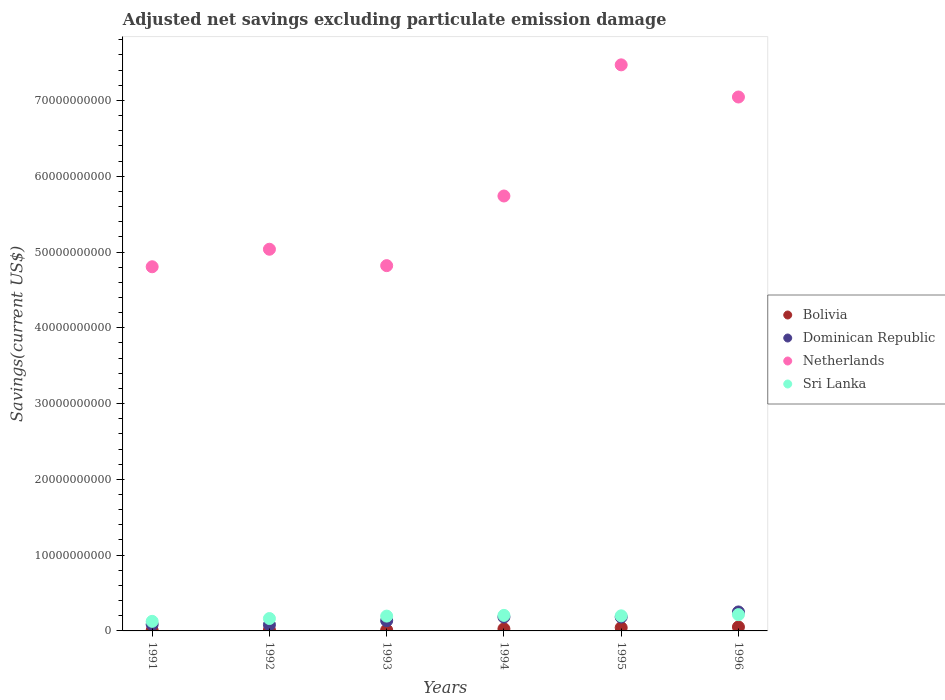What is the adjusted net savings in Dominican Republic in 1995?
Provide a short and direct response. 1.83e+09. Across all years, what is the maximum adjusted net savings in Bolivia?
Your answer should be very brief. 5.21e+08. Across all years, what is the minimum adjusted net savings in Netherlands?
Ensure brevity in your answer.  4.81e+1. In which year was the adjusted net savings in Sri Lanka maximum?
Give a very brief answer. 1996. In which year was the adjusted net savings in Netherlands minimum?
Make the answer very short. 1991. What is the total adjusted net savings in Dominican Republic in the graph?
Your response must be concise. 9.19e+09. What is the difference between the adjusted net savings in Bolivia in 1992 and that in 1995?
Provide a short and direct response. -3.08e+08. What is the difference between the adjusted net savings in Bolivia in 1992 and the adjusted net savings in Netherlands in 1994?
Ensure brevity in your answer.  -5.73e+1. What is the average adjusted net savings in Netherlands per year?
Provide a succinct answer. 5.82e+1. In the year 1996, what is the difference between the adjusted net savings in Sri Lanka and adjusted net savings in Netherlands?
Your response must be concise. -6.83e+1. What is the ratio of the adjusted net savings in Dominican Republic in 1992 to that in 1996?
Your answer should be very brief. 0.33. Is the adjusted net savings in Netherlands in 1991 less than that in 1996?
Provide a succinct answer. Yes. Is the difference between the adjusted net savings in Sri Lanka in 1992 and 1996 greater than the difference between the adjusted net savings in Netherlands in 1992 and 1996?
Your answer should be very brief. Yes. What is the difference between the highest and the second highest adjusted net savings in Bolivia?
Provide a short and direct response. 9.21e+07. What is the difference between the highest and the lowest adjusted net savings in Netherlands?
Keep it short and to the point. 2.66e+1. Is the sum of the adjusted net savings in Dominican Republic in 1993 and 1994 greater than the maximum adjusted net savings in Netherlands across all years?
Provide a short and direct response. No. Is it the case that in every year, the sum of the adjusted net savings in Netherlands and adjusted net savings in Dominican Republic  is greater than the sum of adjusted net savings in Sri Lanka and adjusted net savings in Bolivia?
Your answer should be very brief. No. Is the adjusted net savings in Sri Lanka strictly greater than the adjusted net savings in Bolivia over the years?
Offer a terse response. Yes. Is the adjusted net savings in Bolivia strictly less than the adjusted net savings in Sri Lanka over the years?
Your answer should be compact. Yes. How many years are there in the graph?
Keep it short and to the point. 6. What is the difference between two consecutive major ticks on the Y-axis?
Your answer should be compact. 1.00e+1. Does the graph contain any zero values?
Provide a succinct answer. No. Does the graph contain grids?
Keep it short and to the point. No. What is the title of the graph?
Make the answer very short. Adjusted net savings excluding particulate emission damage. Does "Portugal" appear as one of the legend labels in the graph?
Keep it short and to the point. No. What is the label or title of the Y-axis?
Provide a short and direct response. Savings(current US$). What is the Savings(current US$) in Bolivia in 1991?
Your answer should be very brief. 7.90e+07. What is the Savings(current US$) of Dominican Republic in 1991?
Make the answer very short. 8.60e+08. What is the Savings(current US$) of Netherlands in 1991?
Provide a succinct answer. 4.81e+1. What is the Savings(current US$) in Sri Lanka in 1991?
Provide a succinct answer. 1.26e+09. What is the Savings(current US$) in Bolivia in 1992?
Your answer should be compact. 1.20e+08. What is the Savings(current US$) of Dominican Republic in 1992?
Provide a short and direct response. 8.15e+08. What is the Savings(current US$) in Netherlands in 1992?
Offer a terse response. 5.04e+1. What is the Savings(current US$) in Sri Lanka in 1992?
Your response must be concise. 1.63e+09. What is the Savings(current US$) in Bolivia in 1993?
Provide a succinct answer. 1.12e+08. What is the Savings(current US$) of Dominican Republic in 1993?
Provide a succinct answer. 1.35e+09. What is the Savings(current US$) in Netherlands in 1993?
Ensure brevity in your answer.  4.82e+1. What is the Savings(current US$) of Sri Lanka in 1993?
Keep it short and to the point. 1.96e+09. What is the Savings(current US$) of Bolivia in 1994?
Give a very brief answer. 2.69e+08. What is the Savings(current US$) in Dominican Republic in 1994?
Provide a short and direct response. 1.84e+09. What is the Savings(current US$) in Netherlands in 1994?
Your response must be concise. 5.74e+1. What is the Savings(current US$) of Sri Lanka in 1994?
Offer a terse response. 2.05e+09. What is the Savings(current US$) in Bolivia in 1995?
Give a very brief answer. 4.28e+08. What is the Savings(current US$) in Dominican Republic in 1995?
Your answer should be compact. 1.83e+09. What is the Savings(current US$) of Netherlands in 1995?
Offer a very short reply. 7.47e+1. What is the Savings(current US$) of Sri Lanka in 1995?
Your response must be concise. 1.99e+09. What is the Savings(current US$) of Bolivia in 1996?
Your answer should be very brief. 5.21e+08. What is the Savings(current US$) of Dominican Republic in 1996?
Make the answer very short. 2.50e+09. What is the Savings(current US$) in Netherlands in 1996?
Make the answer very short. 7.05e+1. What is the Savings(current US$) of Sri Lanka in 1996?
Provide a short and direct response. 2.15e+09. Across all years, what is the maximum Savings(current US$) in Bolivia?
Make the answer very short. 5.21e+08. Across all years, what is the maximum Savings(current US$) in Dominican Republic?
Provide a succinct answer. 2.50e+09. Across all years, what is the maximum Savings(current US$) in Netherlands?
Your answer should be very brief. 7.47e+1. Across all years, what is the maximum Savings(current US$) of Sri Lanka?
Offer a terse response. 2.15e+09. Across all years, what is the minimum Savings(current US$) in Bolivia?
Provide a succinct answer. 7.90e+07. Across all years, what is the minimum Savings(current US$) of Dominican Republic?
Your response must be concise. 8.15e+08. Across all years, what is the minimum Savings(current US$) of Netherlands?
Give a very brief answer. 4.81e+1. Across all years, what is the minimum Savings(current US$) in Sri Lanka?
Your answer should be very brief. 1.26e+09. What is the total Savings(current US$) of Bolivia in the graph?
Provide a short and direct response. 1.53e+09. What is the total Savings(current US$) of Dominican Republic in the graph?
Make the answer very short. 9.19e+09. What is the total Savings(current US$) of Netherlands in the graph?
Your answer should be compact. 3.49e+11. What is the total Savings(current US$) of Sri Lanka in the graph?
Your answer should be compact. 1.10e+1. What is the difference between the Savings(current US$) of Bolivia in 1991 and that in 1992?
Keep it short and to the point. -4.12e+07. What is the difference between the Savings(current US$) in Dominican Republic in 1991 and that in 1992?
Provide a short and direct response. 4.44e+07. What is the difference between the Savings(current US$) in Netherlands in 1991 and that in 1992?
Offer a terse response. -2.31e+09. What is the difference between the Savings(current US$) in Sri Lanka in 1991 and that in 1992?
Your response must be concise. -3.70e+08. What is the difference between the Savings(current US$) in Bolivia in 1991 and that in 1993?
Ensure brevity in your answer.  -3.27e+07. What is the difference between the Savings(current US$) in Dominican Republic in 1991 and that in 1993?
Make the answer very short. -4.86e+08. What is the difference between the Savings(current US$) of Netherlands in 1991 and that in 1993?
Give a very brief answer. -1.47e+08. What is the difference between the Savings(current US$) of Sri Lanka in 1991 and that in 1993?
Provide a succinct answer. -6.92e+08. What is the difference between the Savings(current US$) in Bolivia in 1991 and that in 1994?
Provide a succinct answer. -1.90e+08. What is the difference between the Savings(current US$) in Dominican Republic in 1991 and that in 1994?
Your answer should be very brief. -9.76e+08. What is the difference between the Savings(current US$) in Netherlands in 1991 and that in 1994?
Provide a short and direct response. -9.34e+09. What is the difference between the Savings(current US$) in Sri Lanka in 1991 and that in 1994?
Your answer should be compact. -7.87e+08. What is the difference between the Savings(current US$) in Bolivia in 1991 and that in 1995?
Make the answer very short. -3.49e+08. What is the difference between the Savings(current US$) of Dominican Republic in 1991 and that in 1995?
Give a very brief answer. -9.70e+08. What is the difference between the Savings(current US$) of Netherlands in 1991 and that in 1995?
Provide a short and direct response. -2.66e+1. What is the difference between the Savings(current US$) in Sri Lanka in 1991 and that in 1995?
Provide a succinct answer. -7.28e+08. What is the difference between the Savings(current US$) of Bolivia in 1991 and that in 1996?
Give a very brief answer. -4.42e+08. What is the difference between the Savings(current US$) of Dominican Republic in 1991 and that in 1996?
Your answer should be very brief. -1.64e+09. What is the difference between the Savings(current US$) of Netherlands in 1991 and that in 1996?
Give a very brief answer. -2.24e+1. What is the difference between the Savings(current US$) of Sri Lanka in 1991 and that in 1996?
Ensure brevity in your answer.  -8.87e+08. What is the difference between the Savings(current US$) of Bolivia in 1992 and that in 1993?
Give a very brief answer. 8.44e+06. What is the difference between the Savings(current US$) in Dominican Republic in 1992 and that in 1993?
Your answer should be compact. -5.30e+08. What is the difference between the Savings(current US$) of Netherlands in 1992 and that in 1993?
Your answer should be compact. 2.16e+09. What is the difference between the Savings(current US$) in Sri Lanka in 1992 and that in 1993?
Offer a very short reply. -3.22e+08. What is the difference between the Savings(current US$) of Bolivia in 1992 and that in 1994?
Your response must be concise. -1.49e+08. What is the difference between the Savings(current US$) of Dominican Republic in 1992 and that in 1994?
Provide a succinct answer. -1.02e+09. What is the difference between the Savings(current US$) in Netherlands in 1992 and that in 1994?
Offer a very short reply. -7.03e+09. What is the difference between the Savings(current US$) in Sri Lanka in 1992 and that in 1994?
Offer a very short reply. -4.17e+08. What is the difference between the Savings(current US$) of Bolivia in 1992 and that in 1995?
Your answer should be compact. -3.08e+08. What is the difference between the Savings(current US$) of Dominican Republic in 1992 and that in 1995?
Provide a short and direct response. -1.01e+09. What is the difference between the Savings(current US$) in Netherlands in 1992 and that in 1995?
Your response must be concise. -2.43e+1. What is the difference between the Savings(current US$) of Sri Lanka in 1992 and that in 1995?
Give a very brief answer. -3.58e+08. What is the difference between the Savings(current US$) of Bolivia in 1992 and that in 1996?
Provide a succinct answer. -4.00e+08. What is the difference between the Savings(current US$) of Dominican Republic in 1992 and that in 1996?
Offer a very short reply. -1.69e+09. What is the difference between the Savings(current US$) in Netherlands in 1992 and that in 1996?
Provide a succinct answer. -2.01e+1. What is the difference between the Savings(current US$) in Sri Lanka in 1992 and that in 1996?
Provide a succinct answer. -5.17e+08. What is the difference between the Savings(current US$) in Bolivia in 1993 and that in 1994?
Keep it short and to the point. -1.58e+08. What is the difference between the Savings(current US$) in Dominican Republic in 1993 and that in 1994?
Give a very brief answer. -4.90e+08. What is the difference between the Savings(current US$) of Netherlands in 1993 and that in 1994?
Your answer should be compact. -9.19e+09. What is the difference between the Savings(current US$) of Sri Lanka in 1993 and that in 1994?
Your answer should be very brief. -9.50e+07. What is the difference between the Savings(current US$) of Bolivia in 1993 and that in 1995?
Give a very brief answer. -3.17e+08. What is the difference between the Savings(current US$) of Dominican Republic in 1993 and that in 1995?
Your answer should be very brief. -4.85e+08. What is the difference between the Savings(current US$) in Netherlands in 1993 and that in 1995?
Ensure brevity in your answer.  -2.65e+1. What is the difference between the Savings(current US$) of Sri Lanka in 1993 and that in 1995?
Offer a terse response. -3.57e+07. What is the difference between the Savings(current US$) in Bolivia in 1993 and that in 1996?
Your answer should be compact. -4.09e+08. What is the difference between the Savings(current US$) of Dominican Republic in 1993 and that in 1996?
Your response must be concise. -1.16e+09. What is the difference between the Savings(current US$) of Netherlands in 1993 and that in 1996?
Your answer should be compact. -2.23e+1. What is the difference between the Savings(current US$) of Sri Lanka in 1993 and that in 1996?
Give a very brief answer. -1.95e+08. What is the difference between the Savings(current US$) of Bolivia in 1994 and that in 1995?
Provide a succinct answer. -1.59e+08. What is the difference between the Savings(current US$) in Dominican Republic in 1994 and that in 1995?
Your response must be concise. 5.61e+06. What is the difference between the Savings(current US$) in Netherlands in 1994 and that in 1995?
Your response must be concise. -1.73e+1. What is the difference between the Savings(current US$) of Sri Lanka in 1994 and that in 1995?
Your response must be concise. 5.93e+07. What is the difference between the Savings(current US$) in Bolivia in 1994 and that in 1996?
Give a very brief answer. -2.51e+08. What is the difference between the Savings(current US$) in Dominican Republic in 1994 and that in 1996?
Keep it short and to the point. -6.69e+08. What is the difference between the Savings(current US$) of Netherlands in 1994 and that in 1996?
Keep it short and to the point. -1.31e+1. What is the difference between the Savings(current US$) of Sri Lanka in 1994 and that in 1996?
Your response must be concise. -1.00e+08. What is the difference between the Savings(current US$) in Bolivia in 1995 and that in 1996?
Your answer should be compact. -9.21e+07. What is the difference between the Savings(current US$) of Dominican Republic in 1995 and that in 1996?
Make the answer very short. -6.74e+08. What is the difference between the Savings(current US$) of Netherlands in 1995 and that in 1996?
Provide a succinct answer. 4.24e+09. What is the difference between the Savings(current US$) of Sri Lanka in 1995 and that in 1996?
Offer a very short reply. -1.60e+08. What is the difference between the Savings(current US$) of Bolivia in 1991 and the Savings(current US$) of Dominican Republic in 1992?
Provide a short and direct response. -7.36e+08. What is the difference between the Savings(current US$) of Bolivia in 1991 and the Savings(current US$) of Netherlands in 1992?
Make the answer very short. -5.03e+1. What is the difference between the Savings(current US$) of Bolivia in 1991 and the Savings(current US$) of Sri Lanka in 1992?
Your answer should be compact. -1.55e+09. What is the difference between the Savings(current US$) in Dominican Republic in 1991 and the Savings(current US$) in Netherlands in 1992?
Keep it short and to the point. -4.95e+1. What is the difference between the Savings(current US$) of Dominican Republic in 1991 and the Savings(current US$) of Sri Lanka in 1992?
Your answer should be compact. -7.74e+08. What is the difference between the Savings(current US$) of Netherlands in 1991 and the Savings(current US$) of Sri Lanka in 1992?
Your answer should be compact. 4.64e+1. What is the difference between the Savings(current US$) in Bolivia in 1991 and the Savings(current US$) in Dominican Republic in 1993?
Make the answer very short. -1.27e+09. What is the difference between the Savings(current US$) in Bolivia in 1991 and the Savings(current US$) in Netherlands in 1993?
Provide a succinct answer. -4.81e+1. What is the difference between the Savings(current US$) of Bolivia in 1991 and the Savings(current US$) of Sri Lanka in 1993?
Offer a terse response. -1.88e+09. What is the difference between the Savings(current US$) of Dominican Republic in 1991 and the Savings(current US$) of Netherlands in 1993?
Your answer should be very brief. -4.73e+1. What is the difference between the Savings(current US$) of Dominican Republic in 1991 and the Savings(current US$) of Sri Lanka in 1993?
Provide a succinct answer. -1.10e+09. What is the difference between the Savings(current US$) in Netherlands in 1991 and the Savings(current US$) in Sri Lanka in 1993?
Provide a short and direct response. 4.61e+1. What is the difference between the Savings(current US$) in Bolivia in 1991 and the Savings(current US$) in Dominican Republic in 1994?
Provide a succinct answer. -1.76e+09. What is the difference between the Savings(current US$) in Bolivia in 1991 and the Savings(current US$) in Netherlands in 1994?
Give a very brief answer. -5.73e+1. What is the difference between the Savings(current US$) in Bolivia in 1991 and the Savings(current US$) in Sri Lanka in 1994?
Give a very brief answer. -1.97e+09. What is the difference between the Savings(current US$) of Dominican Republic in 1991 and the Savings(current US$) of Netherlands in 1994?
Your response must be concise. -5.65e+1. What is the difference between the Savings(current US$) of Dominican Republic in 1991 and the Savings(current US$) of Sri Lanka in 1994?
Your answer should be very brief. -1.19e+09. What is the difference between the Savings(current US$) of Netherlands in 1991 and the Savings(current US$) of Sri Lanka in 1994?
Provide a short and direct response. 4.60e+1. What is the difference between the Savings(current US$) of Bolivia in 1991 and the Savings(current US$) of Dominican Republic in 1995?
Provide a succinct answer. -1.75e+09. What is the difference between the Savings(current US$) in Bolivia in 1991 and the Savings(current US$) in Netherlands in 1995?
Offer a very short reply. -7.46e+1. What is the difference between the Savings(current US$) in Bolivia in 1991 and the Savings(current US$) in Sri Lanka in 1995?
Make the answer very short. -1.91e+09. What is the difference between the Savings(current US$) in Dominican Republic in 1991 and the Savings(current US$) in Netherlands in 1995?
Offer a terse response. -7.38e+1. What is the difference between the Savings(current US$) of Dominican Republic in 1991 and the Savings(current US$) of Sri Lanka in 1995?
Make the answer very short. -1.13e+09. What is the difference between the Savings(current US$) in Netherlands in 1991 and the Savings(current US$) in Sri Lanka in 1995?
Make the answer very short. 4.61e+1. What is the difference between the Savings(current US$) of Bolivia in 1991 and the Savings(current US$) of Dominican Republic in 1996?
Ensure brevity in your answer.  -2.43e+09. What is the difference between the Savings(current US$) in Bolivia in 1991 and the Savings(current US$) in Netherlands in 1996?
Make the answer very short. -7.04e+1. What is the difference between the Savings(current US$) of Bolivia in 1991 and the Savings(current US$) of Sri Lanka in 1996?
Your answer should be very brief. -2.07e+09. What is the difference between the Savings(current US$) of Dominican Republic in 1991 and the Savings(current US$) of Netherlands in 1996?
Keep it short and to the point. -6.96e+1. What is the difference between the Savings(current US$) of Dominican Republic in 1991 and the Savings(current US$) of Sri Lanka in 1996?
Your answer should be compact. -1.29e+09. What is the difference between the Savings(current US$) in Netherlands in 1991 and the Savings(current US$) in Sri Lanka in 1996?
Your answer should be very brief. 4.59e+1. What is the difference between the Savings(current US$) of Bolivia in 1992 and the Savings(current US$) of Dominican Republic in 1993?
Offer a very short reply. -1.23e+09. What is the difference between the Savings(current US$) of Bolivia in 1992 and the Savings(current US$) of Netherlands in 1993?
Offer a very short reply. -4.81e+1. What is the difference between the Savings(current US$) of Bolivia in 1992 and the Savings(current US$) of Sri Lanka in 1993?
Make the answer very short. -1.84e+09. What is the difference between the Savings(current US$) in Dominican Republic in 1992 and the Savings(current US$) in Netherlands in 1993?
Your answer should be compact. -4.74e+1. What is the difference between the Savings(current US$) of Dominican Republic in 1992 and the Savings(current US$) of Sri Lanka in 1993?
Keep it short and to the point. -1.14e+09. What is the difference between the Savings(current US$) in Netherlands in 1992 and the Savings(current US$) in Sri Lanka in 1993?
Your answer should be compact. 4.84e+1. What is the difference between the Savings(current US$) in Bolivia in 1992 and the Savings(current US$) in Dominican Republic in 1994?
Your answer should be compact. -1.72e+09. What is the difference between the Savings(current US$) of Bolivia in 1992 and the Savings(current US$) of Netherlands in 1994?
Ensure brevity in your answer.  -5.73e+1. What is the difference between the Savings(current US$) in Bolivia in 1992 and the Savings(current US$) in Sri Lanka in 1994?
Your response must be concise. -1.93e+09. What is the difference between the Savings(current US$) of Dominican Republic in 1992 and the Savings(current US$) of Netherlands in 1994?
Ensure brevity in your answer.  -5.66e+1. What is the difference between the Savings(current US$) in Dominican Republic in 1992 and the Savings(current US$) in Sri Lanka in 1994?
Keep it short and to the point. -1.23e+09. What is the difference between the Savings(current US$) of Netherlands in 1992 and the Savings(current US$) of Sri Lanka in 1994?
Provide a short and direct response. 4.83e+1. What is the difference between the Savings(current US$) of Bolivia in 1992 and the Savings(current US$) of Dominican Republic in 1995?
Your answer should be very brief. -1.71e+09. What is the difference between the Savings(current US$) of Bolivia in 1992 and the Savings(current US$) of Netherlands in 1995?
Make the answer very short. -7.46e+1. What is the difference between the Savings(current US$) in Bolivia in 1992 and the Savings(current US$) in Sri Lanka in 1995?
Your response must be concise. -1.87e+09. What is the difference between the Savings(current US$) of Dominican Republic in 1992 and the Savings(current US$) of Netherlands in 1995?
Provide a short and direct response. -7.39e+1. What is the difference between the Savings(current US$) in Dominican Republic in 1992 and the Savings(current US$) in Sri Lanka in 1995?
Keep it short and to the point. -1.18e+09. What is the difference between the Savings(current US$) of Netherlands in 1992 and the Savings(current US$) of Sri Lanka in 1995?
Make the answer very short. 4.84e+1. What is the difference between the Savings(current US$) of Bolivia in 1992 and the Savings(current US$) of Dominican Republic in 1996?
Provide a short and direct response. -2.38e+09. What is the difference between the Savings(current US$) of Bolivia in 1992 and the Savings(current US$) of Netherlands in 1996?
Ensure brevity in your answer.  -7.03e+1. What is the difference between the Savings(current US$) of Bolivia in 1992 and the Savings(current US$) of Sri Lanka in 1996?
Give a very brief answer. -2.03e+09. What is the difference between the Savings(current US$) in Dominican Republic in 1992 and the Savings(current US$) in Netherlands in 1996?
Make the answer very short. -6.96e+1. What is the difference between the Savings(current US$) of Dominican Republic in 1992 and the Savings(current US$) of Sri Lanka in 1996?
Your answer should be very brief. -1.34e+09. What is the difference between the Savings(current US$) in Netherlands in 1992 and the Savings(current US$) in Sri Lanka in 1996?
Your response must be concise. 4.82e+1. What is the difference between the Savings(current US$) of Bolivia in 1993 and the Savings(current US$) of Dominican Republic in 1994?
Offer a very short reply. -1.72e+09. What is the difference between the Savings(current US$) of Bolivia in 1993 and the Savings(current US$) of Netherlands in 1994?
Your response must be concise. -5.73e+1. What is the difference between the Savings(current US$) in Bolivia in 1993 and the Savings(current US$) in Sri Lanka in 1994?
Offer a very short reply. -1.94e+09. What is the difference between the Savings(current US$) of Dominican Republic in 1993 and the Savings(current US$) of Netherlands in 1994?
Offer a very short reply. -5.60e+1. What is the difference between the Savings(current US$) of Dominican Republic in 1993 and the Savings(current US$) of Sri Lanka in 1994?
Offer a very short reply. -7.05e+08. What is the difference between the Savings(current US$) in Netherlands in 1993 and the Savings(current US$) in Sri Lanka in 1994?
Make the answer very short. 4.62e+1. What is the difference between the Savings(current US$) of Bolivia in 1993 and the Savings(current US$) of Dominican Republic in 1995?
Make the answer very short. -1.72e+09. What is the difference between the Savings(current US$) in Bolivia in 1993 and the Savings(current US$) in Netherlands in 1995?
Provide a succinct answer. -7.46e+1. What is the difference between the Savings(current US$) of Bolivia in 1993 and the Savings(current US$) of Sri Lanka in 1995?
Offer a terse response. -1.88e+09. What is the difference between the Savings(current US$) of Dominican Republic in 1993 and the Savings(current US$) of Netherlands in 1995?
Your answer should be very brief. -7.34e+1. What is the difference between the Savings(current US$) in Dominican Republic in 1993 and the Savings(current US$) in Sri Lanka in 1995?
Make the answer very short. -6.45e+08. What is the difference between the Savings(current US$) of Netherlands in 1993 and the Savings(current US$) of Sri Lanka in 1995?
Ensure brevity in your answer.  4.62e+1. What is the difference between the Savings(current US$) of Bolivia in 1993 and the Savings(current US$) of Dominican Republic in 1996?
Give a very brief answer. -2.39e+09. What is the difference between the Savings(current US$) in Bolivia in 1993 and the Savings(current US$) in Netherlands in 1996?
Your response must be concise. -7.03e+1. What is the difference between the Savings(current US$) in Bolivia in 1993 and the Savings(current US$) in Sri Lanka in 1996?
Offer a terse response. -2.04e+09. What is the difference between the Savings(current US$) of Dominican Republic in 1993 and the Savings(current US$) of Netherlands in 1996?
Your answer should be compact. -6.91e+1. What is the difference between the Savings(current US$) of Dominican Republic in 1993 and the Savings(current US$) of Sri Lanka in 1996?
Ensure brevity in your answer.  -8.05e+08. What is the difference between the Savings(current US$) in Netherlands in 1993 and the Savings(current US$) in Sri Lanka in 1996?
Your answer should be compact. 4.60e+1. What is the difference between the Savings(current US$) of Bolivia in 1994 and the Savings(current US$) of Dominican Republic in 1995?
Provide a succinct answer. -1.56e+09. What is the difference between the Savings(current US$) of Bolivia in 1994 and the Savings(current US$) of Netherlands in 1995?
Give a very brief answer. -7.44e+1. What is the difference between the Savings(current US$) of Bolivia in 1994 and the Savings(current US$) of Sri Lanka in 1995?
Offer a very short reply. -1.72e+09. What is the difference between the Savings(current US$) of Dominican Republic in 1994 and the Savings(current US$) of Netherlands in 1995?
Give a very brief answer. -7.29e+1. What is the difference between the Savings(current US$) in Dominican Republic in 1994 and the Savings(current US$) in Sri Lanka in 1995?
Your answer should be very brief. -1.55e+08. What is the difference between the Savings(current US$) in Netherlands in 1994 and the Savings(current US$) in Sri Lanka in 1995?
Keep it short and to the point. 5.54e+1. What is the difference between the Savings(current US$) in Bolivia in 1994 and the Savings(current US$) in Dominican Republic in 1996?
Provide a short and direct response. -2.24e+09. What is the difference between the Savings(current US$) of Bolivia in 1994 and the Savings(current US$) of Netherlands in 1996?
Provide a short and direct response. -7.02e+1. What is the difference between the Savings(current US$) of Bolivia in 1994 and the Savings(current US$) of Sri Lanka in 1996?
Your response must be concise. -1.88e+09. What is the difference between the Savings(current US$) in Dominican Republic in 1994 and the Savings(current US$) in Netherlands in 1996?
Your response must be concise. -6.86e+1. What is the difference between the Savings(current US$) in Dominican Republic in 1994 and the Savings(current US$) in Sri Lanka in 1996?
Provide a succinct answer. -3.15e+08. What is the difference between the Savings(current US$) in Netherlands in 1994 and the Savings(current US$) in Sri Lanka in 1996?
Your answer should be very brief. 5.52e+1. What is the difference between the Savings(current US$) in Bolivia in 1995 and the Savings(current US$) in Dominican Republic in 1996?
Provide a short and direct response. -2.08e+09. What is the difference between the Savings(current US$) in Bolivia in 1995 and the Savings(current US$) in Netherlands in 1996?
Keep it short and to the point. -7.00e+1. What is the difference between the Savings(current US$) in Bolivia in 1995 and the Savings(current US$) in Sri Lanka in 1996?
Your answer should be compact. -1.72e+09. What is the difference between the Savings(current US$) in Dominican Republic in 1995 and the Savings(current US$) in Netherlands in 1996?
Your answer should be compact. -6.86e+1. What is the difference between the Savings(current US$) in Dominican Republic in 1995 and the Savings(current US$) in Sri Lanka in 1996?
Offer a terse response. -3.20e+08. What is the difference between the Savings(current US$) in Netherlands in 1995 and the Savings(current US$) in Sri Lanka in 1996?
Provide a succinct answer. 7.25e+1. What is the average Savings(current US$) of Bolivia per year?
Give a very brief answer. 2.55e+08. What is the average Savings(current US$) of Dominican Republic per year?
Provide a short and direct response. 1.53e+09. What is the average Savings(current US$) in Netherlands per year?
Your answer should be very brief. 5.82e+1. What is the average Savings(current US$) in Sri Lanka per year?
Provide a succinct answer. 1.84e+09. In the year 1991, what is the difference between the Savings(current US$) of Bolivia and Savings(current US$) of Dominican Republic?
Provide a succinct answer. -7.81e+08. In the year 1991, what is the difference between the Savings(current US$) in Bolivia and Savings(current US$) in Netherlands?
Provide a short and direct response. -4.80e+1. In the year 1991, what is the difference between the Savings(current US$) of Bolivia and Savings(current US$) of Sri Lanka?
Your answer should be very brief. -1.18e+09. In the year 1991, what is the difference between the Savings(current US$) of Dominican Republic and Savings(current US$) of Netherlands?
Provide a succinct answer. -4.72e+1. In the year 1991, what is the difference between the Savings(current US$) in Dominican Republic and Savings(current US$) in Sri Lanka?
Offer a very short reply. -4.03e+08. In the year 1991, what is the difference between the Savings(current US$) in Netherlands and Savings(current US$) in Sri Lanka?
Provide a short and direct response. 4.68e+1. In the year 1992, what is the difference between the Savings(current US$) in Bolivia and Savings(current US$) in Dominican Republic?
Provide a short and direct response. -6.95e+08. In the year 1992, what is the difference between the Savings(current US$) of Bolivia and Savings(current US$) of Netherlands?
Offer a terse response. -5.02e+1. In the year 1992, what is the difference between the Savings(current US$) in Bolivia and Savings(current US$) in Sri Lanka?
Offer a terse response. -1.51e+09. In the year 1992, what is the difference between the Savings(current US$) in Dominican Republic and Savings(current US$) in Netherlands?
Provide a succinct answer. -4.95e+1. In the year 1992, what is the difference between the Savings(current US$) of Dominican Republic and Savings(current US$) of Sri Lanka?
Provide a succinct answer. -8.18e+08. In the year 1992, what is the difference between the Savings(current US$) of Netherlands and Savings(current US$) of Sri Lanka?
Offer a terse response. 4.87e+1. In the year 1993, what is the difference between the Savings(current US$) of Bolivia and Savings(current US$) of Dominican Republic?
Make the answer very short. -1.23e+09. In the year 1993, what is the difference between the Savings(current US$) in Bolivia and Savings(current US$) in Netherlands?
Make the answer very short. -4.81e+1. In the year 1993, what is the difference between the Savings(current US$) in Bolivia and Savings(current US$) in Sri Lanka?
Ensure brevity in your answer.  -1.84e+09. In the year 1993, what is the difference between the Savings(current US$) of Dominican Republic and Savings(current US$) of Netherlands?
Keep it short and to the point. -4.69e+1. In the year 1993, what is the difference between the Savings(current US$) of Dominican Republic and Savings(current US$) of Sri Lanka?
Make the answer very short. -6.10e+08. In the year 1993, what is the difference between the Savings(current US$) of Netherlands and Savings(current US$) of Sri Lanka?
Your answer should be compact. 4.62e+1. In the year 1994, what is the difference between the Savings(current US$) in Bolivia and Savings(current US$) in Dominican Republic?
Offer a very short reply. -1.57e+09. In the year 1994, what is the difference between the Savings(current US$) in Bolivia and Savings(current US$) in Netherlands?
Offer a terse response. -5.71e+1. In the year 1994, what is the difference between the Savings(current US$) in Bolivia and Savings(current US$) in Sri Lanka?
Your answer should be compact. -1.78e+09. In the year 1994, what is the difference between the Savings(current US$) in Dominican Republic and Savings(current US$) in Netherlands?
Offer a terse response. -5.56e+1. In the year 1994, what is the difference between the Savings(current US$) of Dominican Republic and Savings(current US$) of Sri Lanka?
Give a very brief answer. -2.14e+08. In the year 1994, what is the difference between the Savings(current US$) in Netherlands and Savings(current US$) in Sri Lanka?
Keep it short and to the point. 5.53e+1. In the year 1995, what is the difference between the Savings(current US$) in Bolivia and Savings(current US$) in Dominican Republic?
Provide a short and direct response. -1.40e+09. In the year 1995, what is the difference between the Savings(current US$) in Bolivia and Savings(current US$) in Netherlands?
Give a very brief answer. -7.43e+1. In the year 1995, what is the difference between the Savings(current US$) in Bolivia and Savings(current US$) in Sri Lanka?
Your response must be concise. -1.56e+09. In the year 1995, what is the difference between the Savings(current US$) of Dominican Republic and Savings(current US$) of Netherlands?
Provide a short and direct response. -7.29e+1. In the year 1995, what is the difference between the Savings(current US$) in Dominican Republic and Savings(current US$) in Sri Lanka?
Provide a short and direct response. -1.61e+08. In the year 1995, what is the difference between the Savings(current US$) in Netherlands and Savings(current US$) in Sri Lanka?
Provide a succinct answer. 7.27e+1. In the year 1996, what is the difference between the Savings(current US$) in Bolivia and Savings(current US$) in Dominican Republic?
Ensure brevity in your answer.  -1.98e+09. In the year 1996, what is the difference between the Savings(current US$) of Bolivia and Savings(current US$) of Netherlands?
Ensure brevity in your answer.  -6.99e+1. In the year 1996, what is the difference between the Savings(current US$) of Bolivia and Savings(current US$) of Sri Lanka?
Make the answer very short. -1.63e+09. In the year 1996, what is the difference between the Savings(current US$) of Dominican Republic and Savings(current US$) of Netherlands?
Offer a terse response. -6.79e+1. In the year 1996, what is the difference between the Savings(current US$) in Dominican Republic and Savings(current US$) in Sri Lanka?
Keep it short and to the point. 3.54e+08. In the year 1996, what is the difference between the Savings(current US$) in Netherlands and Savings(current US$) in Sri Lanka?
Provide a short and direct response. 6.83e+1. What is the ratio of the Savings(current US$) in Bolivia in 1991 to that in 1992?
Your answer should be compact. 0.66. What is the ratio of the Savings(current US$) of Dominican Republic in 1991 to that in 1992?
Your answer should be compact. 1.05. What is the ratio of the Savings(current US$) in Netherlands in 1991 to that in 1992?
Keep it short and to the point. 0.95. What is the ratio of the Savings(current US$) in Sri Lanka in 1991 to that in 1992?
Keep it short and to the point. 0.77. What is the ratio of the Savings(current US$) in Bolivia in 1991 to that in 1993?
Your answer should be compact. 0.71. What is the ratio of the Savings(current US$) of Dominican Republic in 1991 to that in 1993?
Offer a terse response. 0.64. What is the ratio of the Savings(current US$) in Netherlands in 1991 to that in 1993?
Keep it short and to the point. 1. What is the ratio of the Savings(current US$) of Sri Lanka in 1991 to that in 1993?
Offer a terse response. 0.65. What is the ratio of the Savings(current US$) of Bolivia in 1991 to that in 1994?
Offer a terse response. 0.29. What is the ratio of the Savings(current US$) in Dominican Republic in 1991 to that in 1994?
Keep it short and to the point. 0.47. What is the ratio of the Savings(current US$) of Netherlands in 1991 to that in 1994?
Ensure brevity in your answer.  0.84. What is the ratio of the Savings(current US$) in Sri Lanka in 1991 to that in 1994?
Provide a short and direct response. 0.62. What is the ratio of the Savings(current US$) in Bolivia in 1991 to that in 1995?
Your answer should be compact. 0.18. What is the ratio of the Savings(current US$) of Dominican Republic in 1991 to that in 1995?
Give a very brief answer. 0.47. What is the ratio of the Savings(current US$) in Netherlands in 1991 to that in 1995?
Offer a terse response. 0.64. What is the ratio of the Savings(current US$) in Sri Lanka in 1991 to that in 1995?
Your answer should be very brief. 0.63. What is the ratio of the Savings(current US$) in Bolivia in 1991 to that in 1996?
Keep it short and to the point. 0.15. What is the ratio of the Savings(current US$) in Dominican Republic in 1991 to that in 1996?
Offer a terse response. 0.34. What is the ratio of the Savings(current US$) of Netherlands in 1991 to that in 1996?
Your answer should be very brief. 0.68. What is the ratio of the Savings(current US$) of Sri Lanka in 1991 to that in 1996?
Your response must be concise. 0.59. What is the ratio of the Savings(current US$) of Bolivia in 1992 to that in 1993?
Offer a very short reply. 1.08. What is the ratio of the Savings(current US$) of Dominican Republic in 1992 to that in 1993?
Your answer should be very brief. 0.61. What is the ratio of the Savings(current US$) in Netherlands in 1992 to that in 1993?
Your response must be concise. 1.04. What is the ratio of the Savings(current US$) of Sri Lanka in 1992 to that in 1993?
Give a very brief answer. 0.84. What is the ratio of the Savings(current US$) in Bolivia in 1992 to that in 1994?
Provide a succinct answer. 0.45. What is the ratio of the Savings(current US$) of Dominican Republic in 1992 to that in 1994?
Ensure brevity in your answer.  0.44. What is the ratio of the Savings(current US$) of Netherlands in 1992 to that in 1994?
Provide a succinct answer. 0.88. What is the ratio of the Savings(current US$) of Sri Lanka in 1992 to that in 1994?
Provide a succinct answer. 0.8. What is the ratio of the Savings(current US$) of Bolivia in 1992 to that in 1995?
Keep it short and to the point. 0.28. What is the ratio of the Savings(current US$) of Dominican Republic in 1992 to that in 1995?
Keep it short and to the point. 0.45. What is the ratio of the Savings(current US$) in Netherlands in 1992 to that in 1995?
Your response must be concise. 0.67. What is the ratio of the Savings(current US$) of Sri Lanka in 1992 to that in 1995?
Provide a short and direct response. 0.82. What is the ratio of the Savings(current US$) of Bolivia in 1992 to that in 1996?
Give a very brief answer. 0.23. What is the ratio of the Savings(current US$) in Dominican Republic in 1992 to that in 1996?
Keep it short and to the point. 0.33. What is the ratio of the Savings(current US$) in Netherlands in 1992 to that in 1996?
Offer a terse response. 0.71. What is the ratio of the Savings(current US$) in Sri Lanka in 1992 to that in 1996?
Make the answer very short. 0.76. What is the ratio of the Savings(current US$) in Bolivia in 1993 to that in 1994?
Offer a very short reply. 0.41. What is the ratio of the Savings(current US$) of Dominican Republic in 1993 to that in 1994?
Make the answer very short. 0.73. What is the ratio of the Savings(current US$) in Netherlands in 1993 to that in 1994?
Provide a succinct answer. 0.84. What is the ratio of the Savings(current US$) in Sri Lanka in 1993 to that in 1994?
Make the answer very short. 0.95. What is the ratio of the Savings(current US$) in Bolivia in 1993 to that in 1995?
Your response must be concise. 0.26. What is the ratio of the Savings(current US$) in Dominican Republic in 1993 to that in 1995?
Give a very brief answer. 0.74. What is the ratio of the Savings(current US$) of Netherlands in 1993 to that in 1995?
Make the answer very short. 0.65. What is the ratio of the Savings(current US$) of Sri Lanka in 1993 to that in 1995?
Give a very brief answer. 0.98. What is the ratio of the Savings(current US$) of Bolivia in 1993 to that in 1996?
Your answer should be very brief. 0.21. What is the ratio of the Savings(current US$) in Dominican Republic in 1993 to that in 1996?
Make the answer very short. 0.54. What is the ratio of the Savings(current US$) in Netherlands in 1993 to that in 1996?
Offer a terse response. 0.68. What is the ratio of the Savings(current US$) of Sri Lanka in 1993 to that in 1996?
Ensure brevity in your answer.  0.91. What is the ratio of the Savings(current US$) in Bolivia in 1994 to that in 1995?
Provide a short and direct response. 0.63. What is the ratio of the Savings(current US$) of Netherlands in 1994 to that in 1995?
Keep it short and to the point. 0.77. What is the ratio of the Savings(current US$) of Sri Lanka in 1994 to that in 1995?
Offer a very short reply. 1.03. What is the ratio of the Savings(current US$) in Bolivia in 1994 to that in 1996?
Give a very brief answer. 0.52. What is the ratio of the Savings(current US$) of Dominican Republic in 1994 to that in 1996?
Keep it short and to the point. 0.73. What is the ratio of the Savings(current US$) in Netherlands in 1994 to that in 1996?
Provide a succinct answer. 0.81. What is the ratio of the Savings(current US$) of Sri Lanka in 1994 to that in 1996?
Provide a short and direct response. 0.95. What is the ratio of the Savings(current US$) in Bolivia in 1995 to that in 1996?
Ensure brevity in your answer.  0.82. What is the ratio of the Savings(current US$) in Dominican Republic in 1995 to that in 1996?
Your response must be concise. 0.73. What is the ratio of the Savings(current US$) of Netherlands in 1995 to that in 1996?
Keep it short and to the point. 1.06. What is the ratio of the Savings(current US$) of Sri Lanka in 1995 to that in 1996?
Ensure brevity in your answer.  0.93. What is the difference between the highest and the second highest Savings(current US$) of Bolivia?
Offer a terse response. 9.21e+07. What is the difference between the highest and the second highest Savings(current US$) in Dominican Republic?
Ensure brevity in your answer.  6.69e+08. What is the difference between the highest and the second highest Savings(current US$) of Netherlands?
Make the answer very short. 4.24e+09. What is the difference between the highest and the second highest Savings(current US$) in Sri Lanka?
Make the answer very short. 1.00e+08. What is the difference between the highest and the lowest Savings(current US$) in Bolivia?
Keep it short and to the point. 4.42e+08. What is the difference between the highest and the lowest Savings(current US$) of Dominican Republic?
Offer a very short reply. 1.69e+09. What is the difference between the highest and the lowest Savings(current US$) of Netherlands?
Offer a terse response. 2.66e+1. What is the difference between the highest and the lowest Savings(current US$) in Sri Lanka?
Make the answer very short. 8.87e+08. 